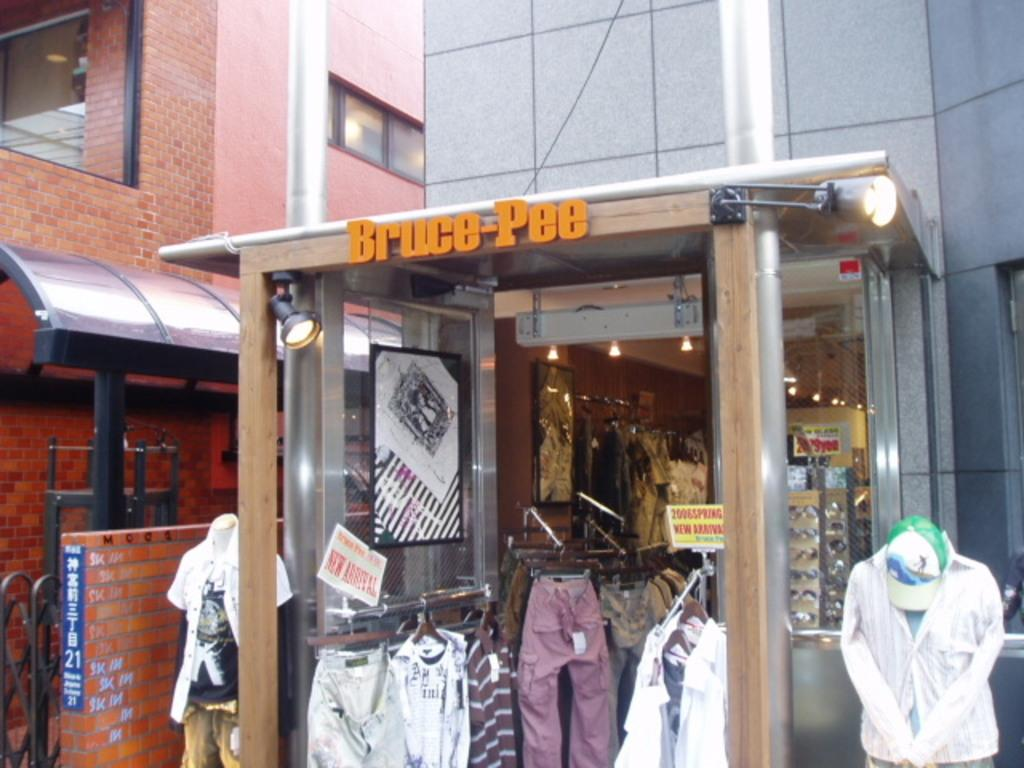<image>
Create a compact narrative representing the image presented. A store front for Bruce Pee with clothes in the entrance 